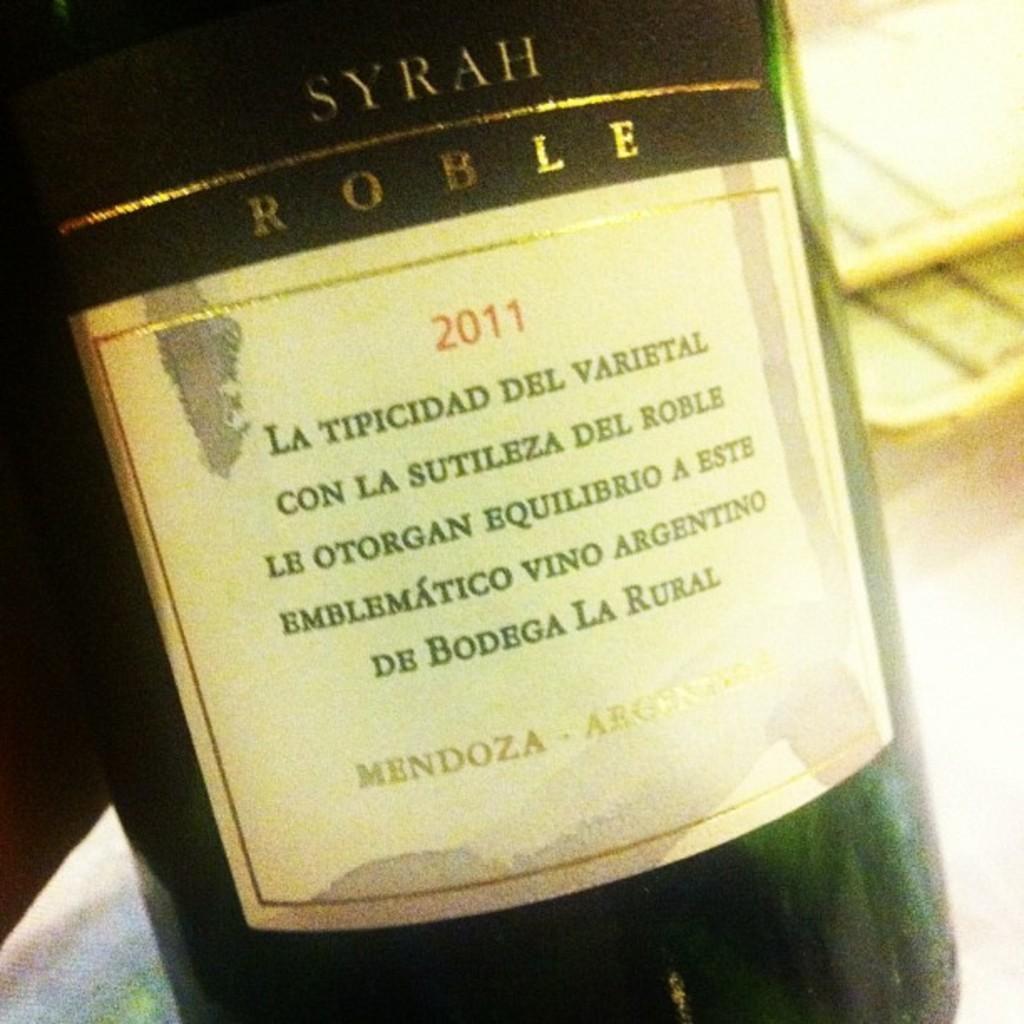Please provide a concise description of this image. In this image I can see there is a wine bottle and there is a label on it, the background of the image is blurred. 